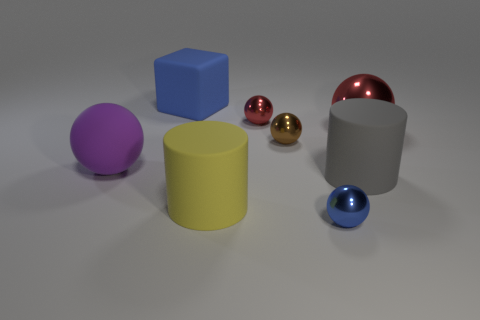Are there any blue metal balls that have the same size as the purple rubber object?
Offer a terse response. No. There is a sphere to the left of the blue matte thing; what is its size?
Give a very brief answer. Large. Is there a tiny red sphere that is right of the big thing on the left side of the big blue rubber thing?
Keep it short and to the point. Yes. What number of other things are there of the same shape as the tiny brown metal thing?
Offer a terse response. 4. Does the big shiny thing have the same shape as the blue matte object?
Your answer should be very brief. No. What color is the matte thing that is on the right side of the block and behind the large yellow cylinder?
Your answer should be compact. Gray. What size is the shiny ball that is the same color as the matte cube?
Offer a terse response. Small. What number of small objects are either blue rubber cubes or green metallic cubes?
Your answer should be very brief. 0. Is there any other thing of the same color as the matte block?
Ensure brevity in your answer.  Yes. The sphere that is right of the big cylinder behind the big cylinder in front of the big gray matte object is made of what material?
Make the answer very short. Metal. 